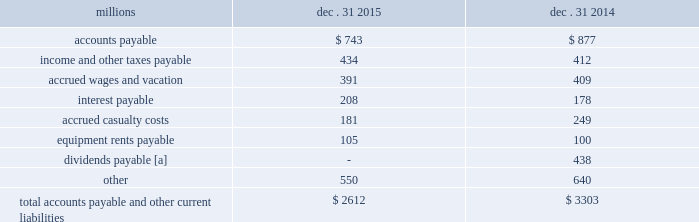Appropriate statistical bases .
Total expense for repairs and maintenance incurred was $ 2.5 billion for 2015 , $ 2.4 billion for 2014 , and $ 2.3 billion for 2013 .
Assets held under capital leases are recorded at the lower of the net present value of the minimum lease payments or the fair value of the leased asset at the inception of the lease .
Amortization expense is computed using the straight-line method over the shorter of the estimated useful lives of the assets or the period of the related lease .
13 .
Accounts payable and other current liabilities dec .
31 , dec .
31 , millions 2015 2014 .
[a] beginning in 2015 , the timing of the dividend declaration and payable dates was aligned to occur within the same quarter .
The 2015 dividends paid amount includes the fourth quarter 2014 dividend of $ 438 million , which was paid on january 2 , 2015 , the first quarter 2015 dividend of $ 484 million , which was paid on march 30 , 2015 , the second quarter 2015 dividend of $ 479 million , which was paid on june 30 , 2015 , the third quarter 2015 dividend of $ 476 million , which was paid on september 30 , 2015 , as well as the fourth quarter 2015 dividend of $ 467 million , which was paid on december 30 , 2015 .
14 .
Financial instruments strategy and risk 2013 we may use derivative financial instruments in limited instances for other than trading purposes to assist in managing our overall exposure to fluctuations in interest rates and fuel prices .
We are not a party to leveraged derivatives and , by policy , do not use derivative financial instruments for speculative purposes .
Derivative financial instruments qualifying for hedge accounting must maintain a specified level of effectiveness between the hedging instrument and the item being hedged , both at inception and throughout the hedged period .
We formally document the nature and relationships between the hedging instruments and hedged items at inception , as well as our risk- management objectives , strategies for undertaking the various hedge transactions , and method of assessing hedge effectiveness .
Changes in the fair market value of derivative financial instruments that do not qualify for hedge accounting are charged to earnings .
We may use swaps , collars , futures , and/or forward contracts to mitigate the risk of adverse movements in interest rates and fuel prices ; however , the use of these derivative financial instruments may limit future benefits from favorable interest rate and fuel price movements .
Market and credit risk 2013 we address market risk related to derivative financial instruments by selecting instruments with value fluctuations that highly correlate with the underlying hedged item .
We manage credit risk related to derivative financial instruments , which is minimal , by requiring high credit standards for counterparties and periodic settlements .
At december 31 , 2015 , and 2014 , we were not required to provide collateral , nor had we received collateral , relating to our hedging activities .
Interest rate fair value hedges 2013 we manage our overall exposure to fluctuations in interest rates by adjusting the proportion of fixed and floating rate debt instruments within our debt portfolio over a given period .
We generally manage the mix of fixed and floating rate debt through the issuance of targeted amounts of each as debt matures or as we require incremental borrowings .
We employ derivatives , primarily swaps , as one of the tools to obtain the targeted mix .
In addition , we also obtain flexibility in managing interest costs and the interest rate mix within our debt portfolio by evaluating the issuance of and managing outstanding callable fixed-rate debt securities .
Swaps allow us to convert debt from fixed rates to variable rates and thereby hedge the risk of changes in the debt 2019s fair value attributable to the changes in interest rates .
We account for swaps as fair value hedges using the short-cut method ; therefore , we do not record any ineffectiveness within our .
What was the percentage change in accrued wages and vacation from 2014 to 2015? 
Computations: ((391 - 409) / 409)
Answer: -0.04401. 